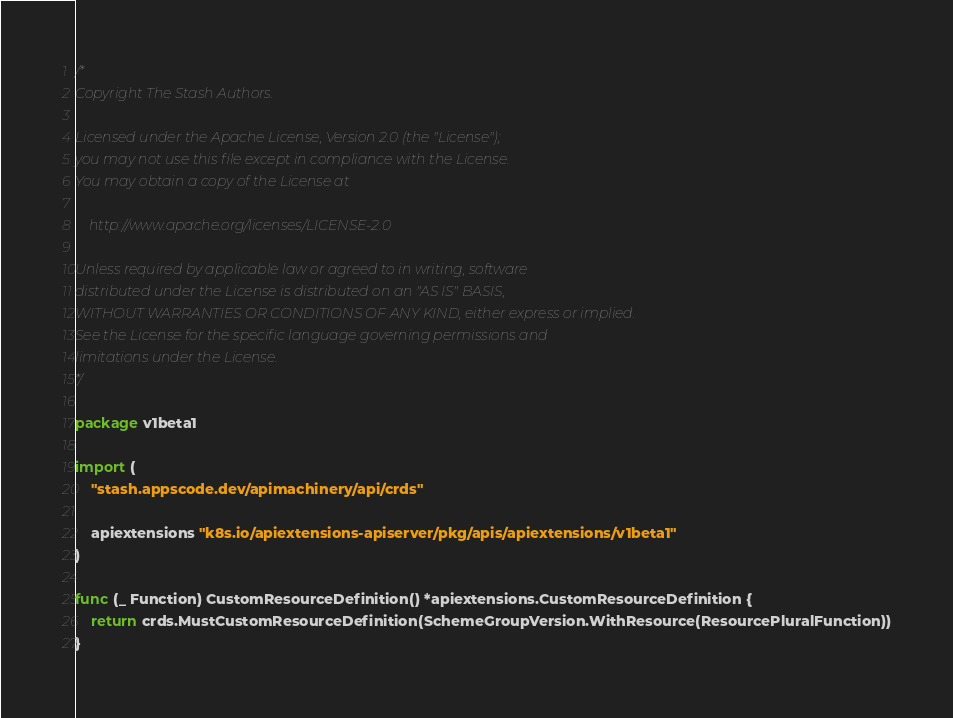<code> <loc_0><loc_0><loc_500><loc_500><_Go_>/*
Copyright The Stash Authors.

Licensed under the Apache License, Version 2.0 (the "License");
you may not use this file except in compliance with the License.
You may obtain a copy of the License at

    http://www.apache.org/licenses/LICENSE-2.0

Unless required by applicable law or agreed to in writing, software
distributed under the License is distributed on an "AS IS" BASIS,
WITHOUT WARRANTIES OR CONDITIONS OF ANY KIND, either express or implied.
See the License for the specific language governing permissions and
limitations under the License.
*/

package v1beta1

import (
	"stash.appscode.dev/apimachinery/api/crds"

	apiextensions "k8s.io/apiextensions-apiserver/pkg/apis/apiextensions/v1beta1"
)

func (_ Function) CustomResourceDefinition() *apiextensions.CustomResourceDefinition {
	return crds.MustCustomResourceDefinition(SchemeGroupVersion.WithResource(ResourcePluralFunction))
}
</code> 